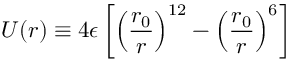<formula> <loc_0><loc_0><loc_500><loc_500>U ( r ) \equiv 4 \epsilon \left [ \left ( \frac { r _ { 0 } } { r } \right ) ^ { 1 2 } - \left ( \frac { r _ { 0 } } { r } \right ) ^ { 6 } \right ]</formula> 